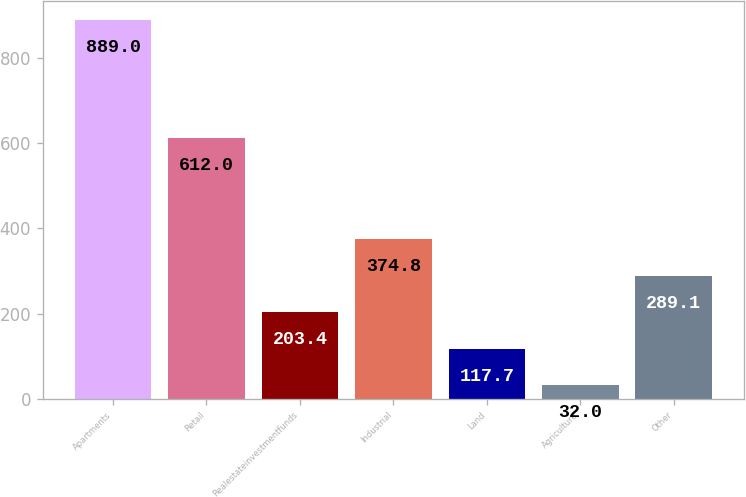Convert chart. <chart><loc_0><loc_0><loc_500><loc_500><bar_chart><fcel>Apartments<fcel>Retail<fcel>Realestateinvestmentfunds<fcel>Industrial<fcel>Land<fcel>Agriculture<fcel>Other<nl><fcel>889<fcel>612<fcel>203.4<fcel>374.8<fcel>117.7<fcel>32<fcel>289.1<nl></chart> 